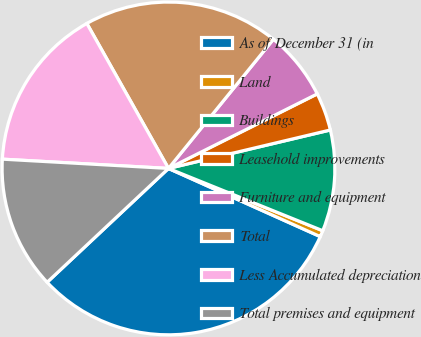Convert chart to OTSL. <chart><loc_0><loc_0><loc_500><loc_500><pie_chart><fcel>As of December 31 (in<fcel>Land<fcel>Buildings<fcel>Leasehold improvements<fcel>Furniture and equipment<fcel>Total<fcel>Less Accumulated depreciation<fcel>Total premises and equipment<nl><fcel>31.29%<fcel>0.61%<fcel>9.82%<fcel>3.68%<fcel>6.75%<fcel>19.02%<fcel>15.95%<fcel>12.88%<nl></chart> 